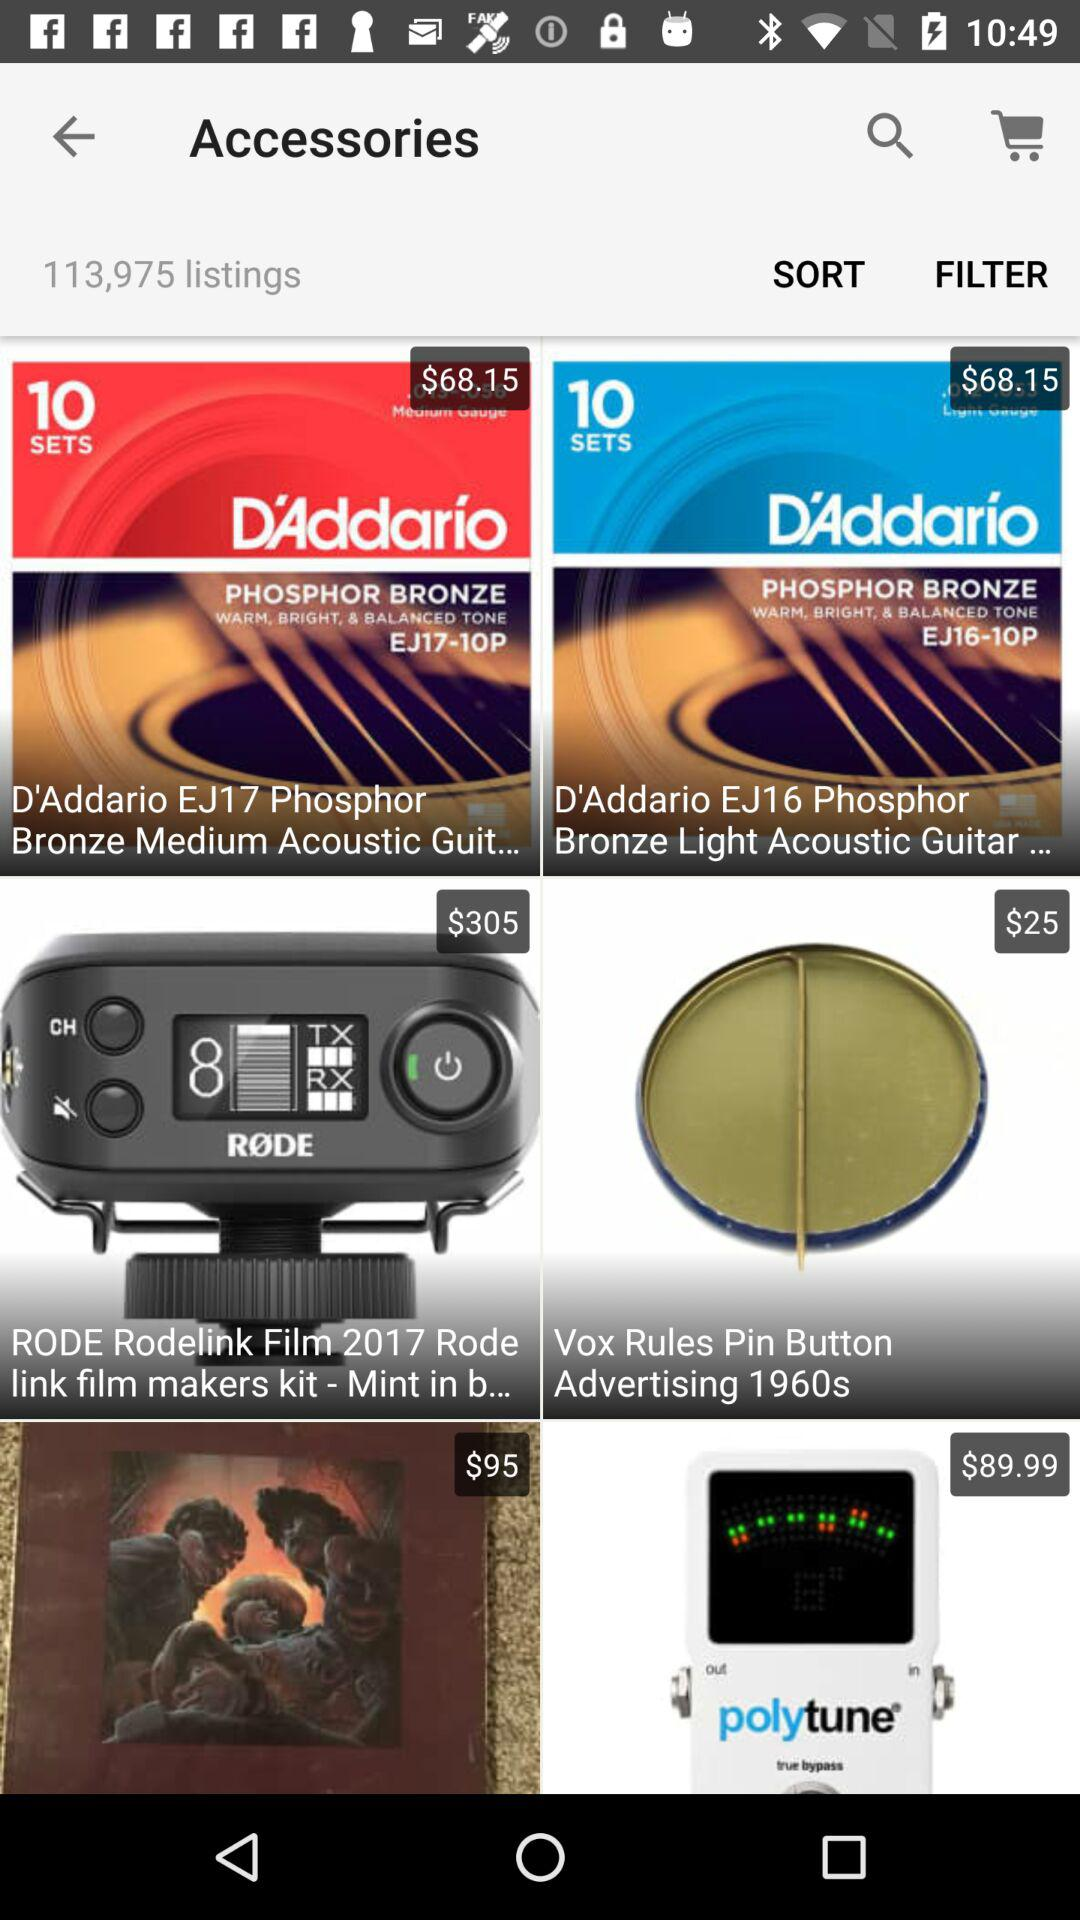How many listings are there? There are 113,975 listings. 